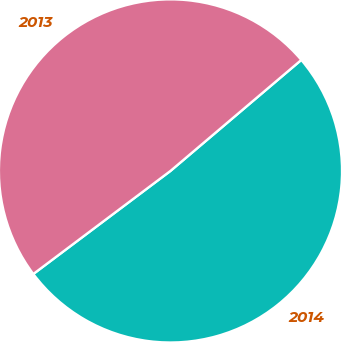Convert chart to OTSL. <chart><loc_0><loc_0><loc_500><loc_500><pie_chart><fcel>2014<fcel>2013<nl><fcel>50.94%<fcel>49.06%<nl></chart> 